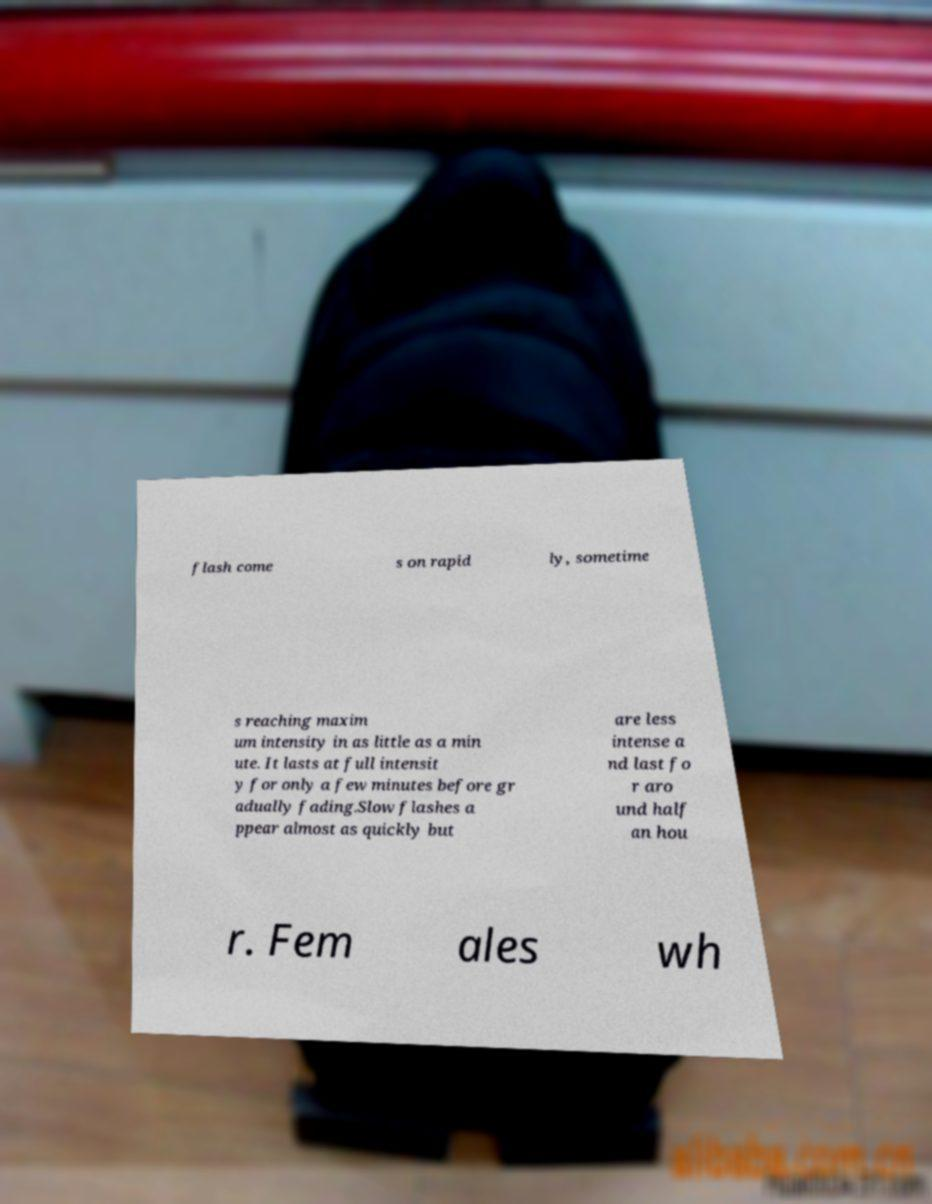There's text embedded in this image that I need extracted. Can you transcribe it verbatim? flash come s on rapid ly, sometime s reaching maxim um intensity in as little as a min ute. It lasts at full intensit y for only a few minutes before gr adually fading.Slow flashes a ppear almost as quickly but are less intense a nd last fo r aro und half an hou r. Fem ales wh 